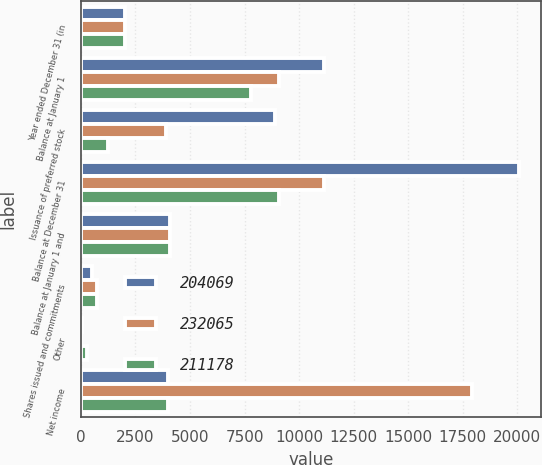<chart> <loc_0><loc_0><loc_500><loc_500><stacked_bar_chart><ecel><fcel>Year ended December 31 (in<fcel>Balance at January 1<fcel>Issuance of preferred stock<fcel>Balance at December 31<fcel>Balance at January 1 and<fcel>Shares issued and commitments<fcel>Other<fcel>Net income<nl><fcel>204069<fcel>2014<fcel>11158<fcel>8905<fcel>20063<fcel>4105<fcel>508<fcel>50<fcel>4002.5<nl><fcel>232065<fcel>2013<fcel>9058<fcel>3900<fcel>11158<fcel>4105<fcel>752<fcel>24<fcel>17923<nl><fcel>211178<fcel>2012<fcel>7800<fcel>1258<fcel>9058<fcel>4105<fcel>736<fcel>262<fcel>4002.5<nl></chart> 